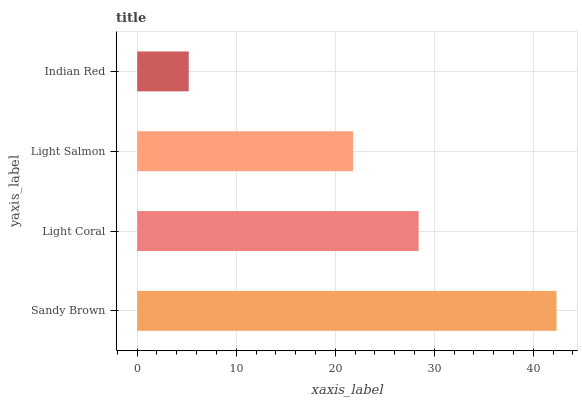Is Indian Red the minimum?
Answer yes or no. Yes. Is Sandy Brown the maximum?
Answer yes or no. Yes. Is Light Coral the minimum?
Answer yes or no. No. Is Light Coral the maximum?
Answer yes or no. No. Is Sandy Brown greater than Light Coral?
Answer yes or no. Yes. Is Light Coral less than Sandy Brown?
Answer yes or no. Yes. Is Light Coral greater than Sandy Brown?
Answer yes or no. No. Is Sandy Brown less than Light Coral?
Answer yes or no. No. Is Light Coral the high median?
Answer yes or no. Yes. Is Light Salmon the low median?
Answer yes or no. Yes. Is Indian Red the high median?
Answer yes or no. No. Is Sandy Brown the low median?
Answer yes or no. No. 